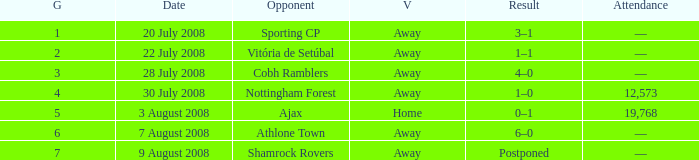What is the complete game tally with athlone town as the rival? 1.0. Can you give me this table as a dict? {'header': ['G', 'Date', 'Opponent', 'V', 'Result', 'Attendance'], 'rows': [['1', '20 July 2008', 'Sporting CP', 'Away', '3–1', '—'], ['2', '22 July 2008', 'Vitória de Setúbal', 'Away', '1–1', '—'], ['3', '28 July 2008', 'Cobh Ramblers', 'Away', '4–0', '—'], ['4', '30 July 2008', 'Nottingham Forest', 'Away', '1–0', '12,573'], ['5', '3 August 2008', 'Ajax', 'Home', '0–1', '19,768'], ['6', '7 August 2008', 'Athlone Town', 'Away', '6–0', '—'], ['7', '9 August 2008', 'Shamrock Rovers', 'Away', 'Postponed', '—']]} 